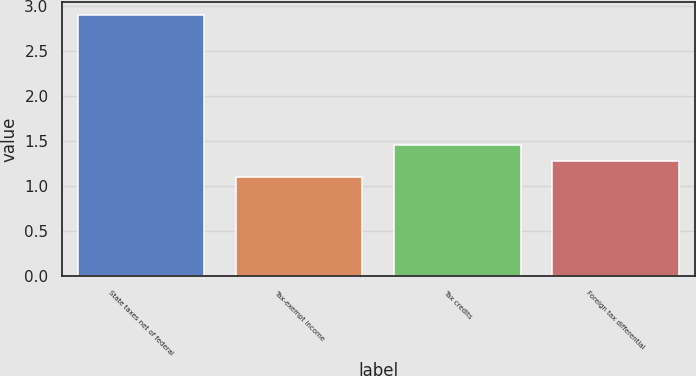<chart> <loc_0><loc_0><loc_500><loc_500><bar_chart><fcel>State taxes net of federal<fcel>Tax-exempt income<fcel>Tax credits<fcel>Foreign tax differential<nl><fcel>2.9<fcel>1.1<fcel>1.46<fcel>1.28<nl></chart> 